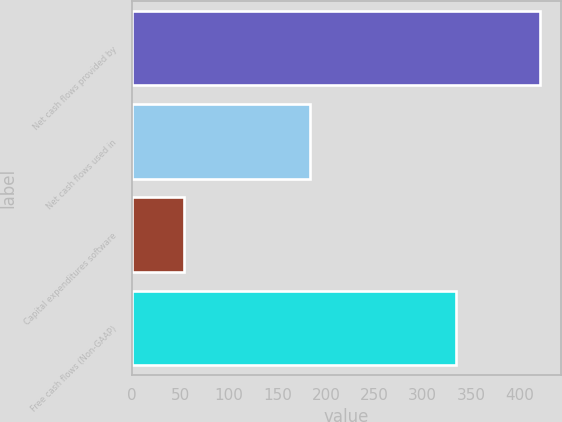Convert chart. <chart><loc_0><loc_0><loc_500><loc_500><bar_chart><fcel>Net cash flows provided by<fcel>Net cash flows used in<fcel>Capital expenditures software<fcel>Free cash flows (Non-GAAP)<nl><fcel>421.13<fcel>183.73<fcel>53.4<fcel>334.3<nl></chart> 